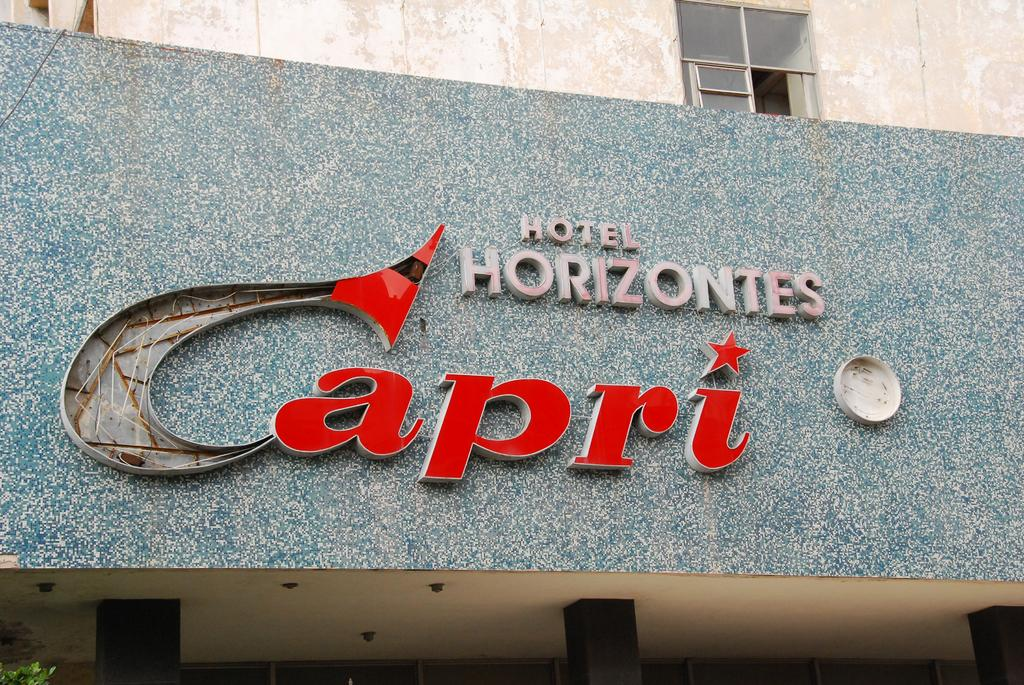<image>
Render a clear and concise summary of the photo. A large blue building front the the words Hotel Horizontes on it. 